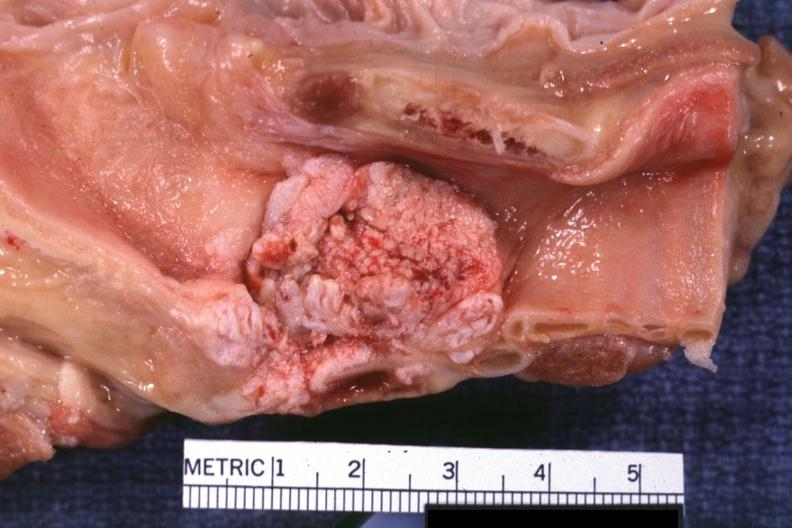where is this?
Answer the question using a single word or phrase. Oral 